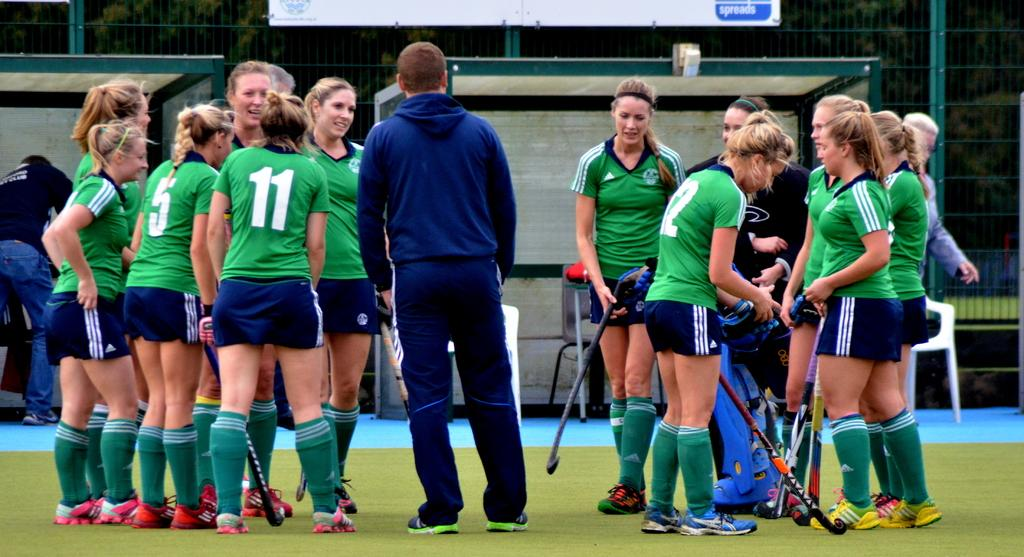<image>
Render a clear and concise summary of the photo. a group if girls in green with one wearing the number 11 